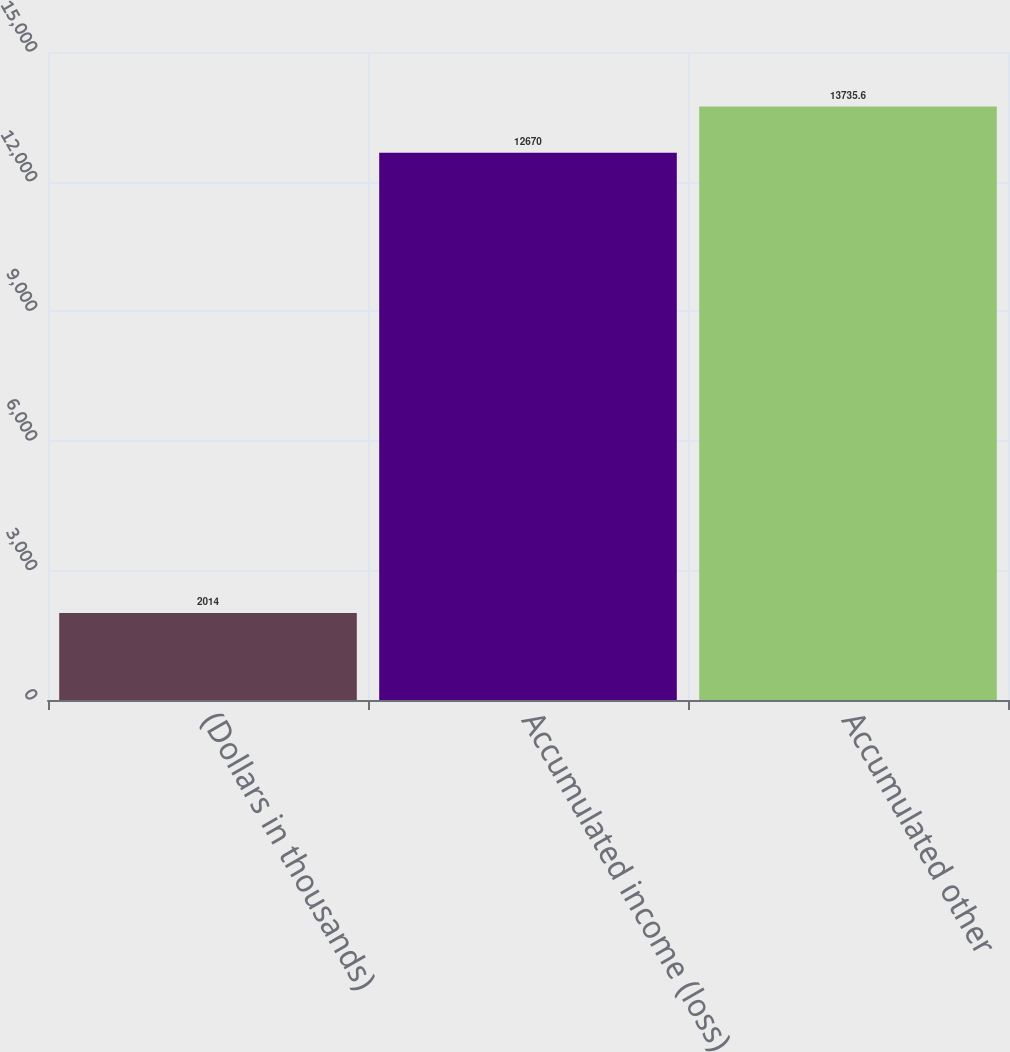<chart> <loc_0><loc_0><loc_500><loc_500><bar_chart><fcel>(Dollars in thousands)<fcel>Accumulated income (loss)<fcel>Accumulated other<nl><fcel>2014<fcel>12670<fcel>13735.6<nl></chart> 